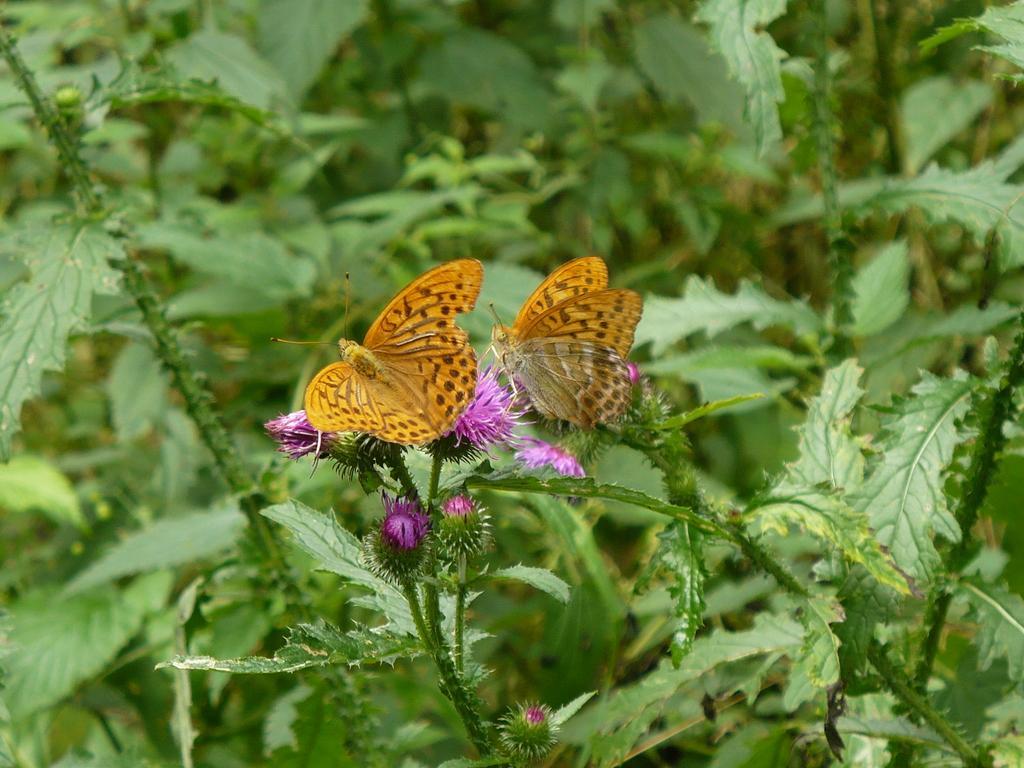Please provide a concise description of this image. In this image there are butterflies sitting on the flowers and there are plants in the background. 